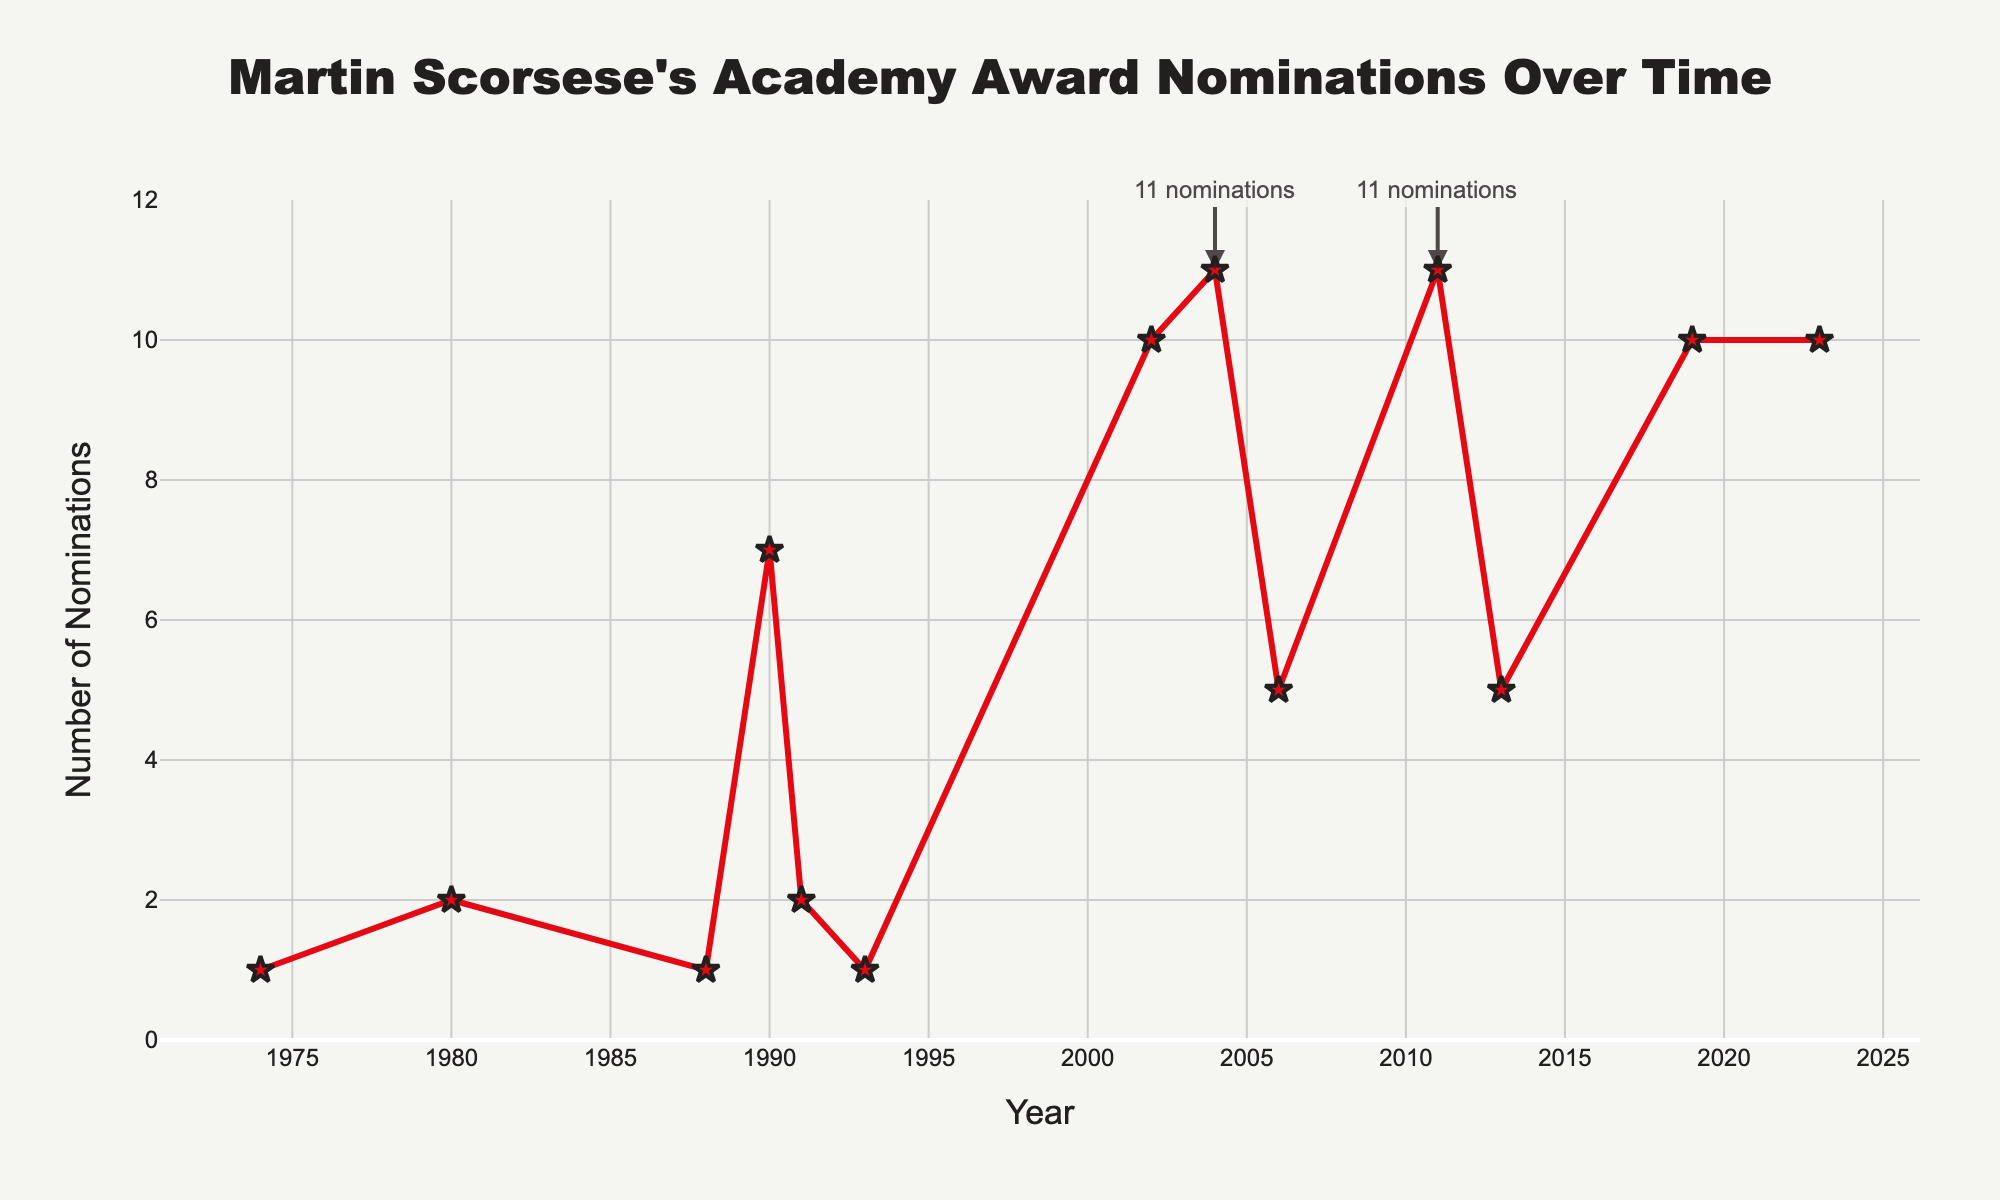Which year did Martin Scorsese's films receive the highest number of Academy Award nominations? The highest number of Academy Award nominations received by his films is 11. According to the figure, this occurred in 2004 and 2011.
Answer: 2004 and 2011 How many total Academy Award nominations did Martin Scorsese's films receive from 1990 to 2019? Add the nominations from each year between 1990 and 2019: 7 (1990) + 2 (1991) + 1 (1993) + 10 (2002) + 11 (2004) + 5 (2006) + 11 (2011) + 5 (2013) + 10 (2019) = 62.
Answer: 62 Which decade saw the highest cumulative number of Academy Award nominations for Scorsese's films? Sum the nominations per decade: 
1970s: 1 
1980s: 3 
1990s: 10 
2000s: 26 
2010s: 26 
2020s: 10 
The 2000s and 2010s each had the highest cumulative nominations with 26.
Answer: 2000s and 2010s How does the number of Academy Award nominations in 1980 compare to that in 1990? In 1980, the number of nominations was 2. In 1990, it was 7. Thus, the nominations in 1990 were greater than in 1980.
Answer: 1990 > 1980 What is the average number of Academy Award nominations received per film for the years shown? To find the average, add all the nominations and divide by the number of years listed: (1 + 2 + 1 + 7 + 2 + 1 + 10 + 11 + 5 + 11 + 5 + 10 + 10) / 13 = 76 / 13 ≈ 5.85 nominations per year.
Answer: 5.85 In how many years did Martin Scorsese's films receive more than 5 Academy Award nominations? According to the figure, more than 5 nominations were received in the years 1990, 2002, 2004, 2011, 2013, 2019, and 2023. Counting these, we get 7 years.
Answer: 7 Did Martin Scorsese's films receive more Academy Award nominations in the first half (1974-1996) or the second half (2000-2023) of the timeframe shown? First, sum the nominations for each half. For 1974-1996: 1 (1974) + 2 (1980) + 1 (1988) + 7 (1990) + 2 (1991) + 1 (1993) = 14 nominations. For 2000-2023: 10 (2002) + 11 (2004) + 5 (2006) + 11 (2011) + 5 (2013) + 10 (2019) + 10 (2023) = 62 nominations. The second half has more nominations.
Answer: Second half In which year did Martin Scorsese's films experience the biggest increase in Academy Award nominations compared to the previous year? Calculate the differences between consecutive years: 
1980-1974: 2 - 1 = 1
1988-1980: 1 - 2 = -1
1990-1988: 7 - 1 = 6
1991-1990: 2 - 7 = -5
1993-1991: 1 - 2 = -1
2002-1993: 10 - 1 = 9
2004-2002: 11 - 10 = 1
2006-2004: 5 - 11 = -6
2011-2006: 11 - 5 = 6
2013-2011: 5 - 11 = -6
2019-2013: 10 - 5 = 5
2023-2019: 10 - 10 = 0
The year with the biggest increase is 2002, with an increase of 9 nominations compared to 1993.
Answer: 2002 